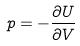<formula> <loc_0><loc_0><loc_500><loc_500>p = - \frac { \partial U } { \partial V }</formula> 